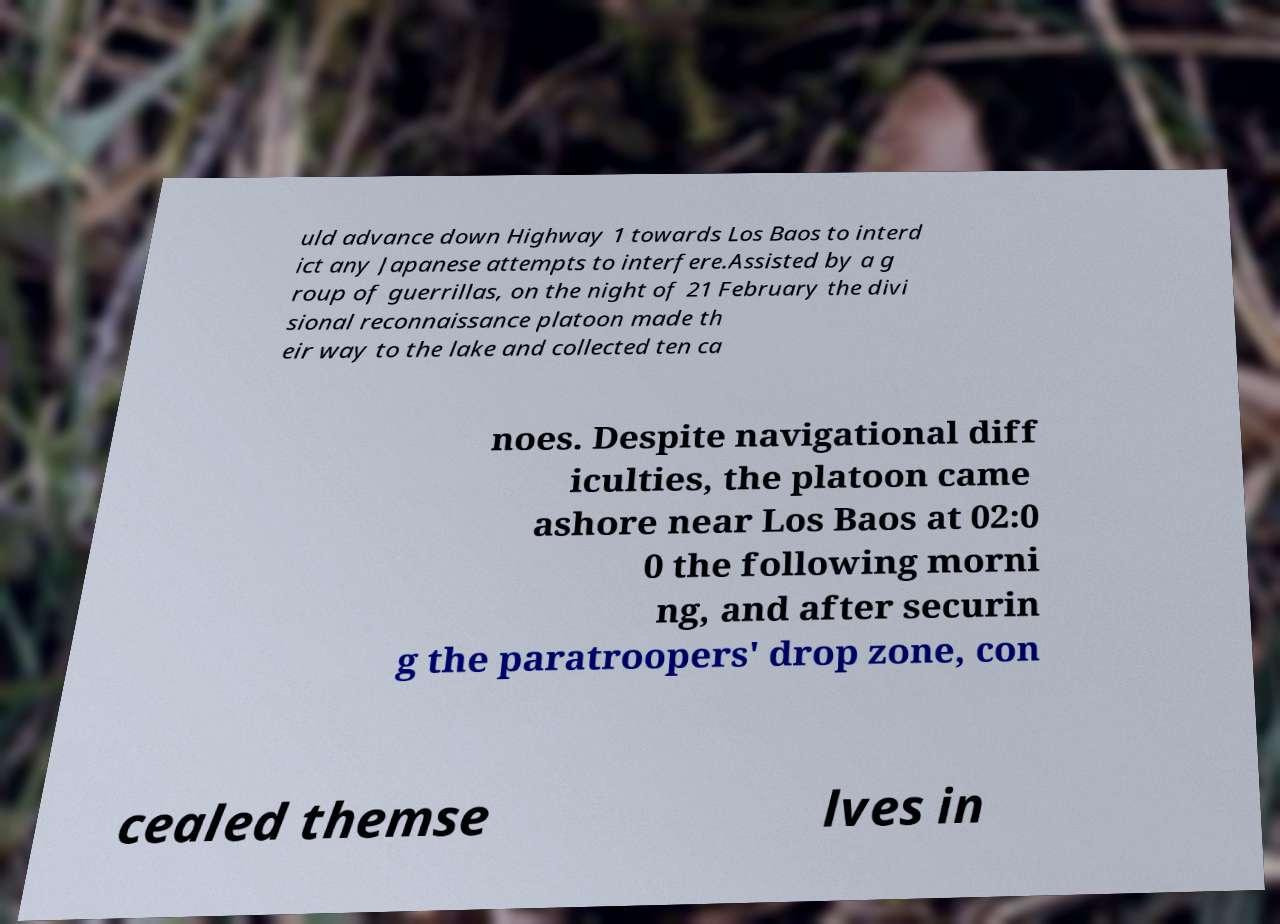Please read and relay the text visible in this image. What does it say? uld advance down Highway 1 towards Los Baos to interd ict any Japanese attempts to interfere.Assisted by a g roup of guerrillas, on the night of 21 February the divi sional reconnaissance platoon made th eir way to the lake and collected ten ca noes. Despite navigational diff iculties, the platoon came ashore near Los Baos at 02:0 0 the following morni ng, and after securin g the paratroopers' drop zone, con cealed themse lves in 